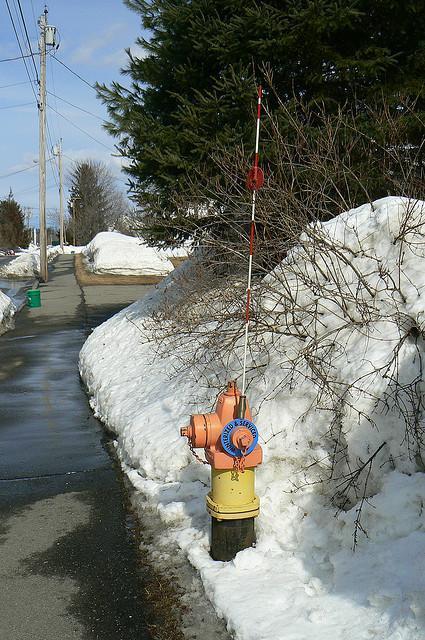How many orange cones can you see?
Give a very brief answer. 0. 